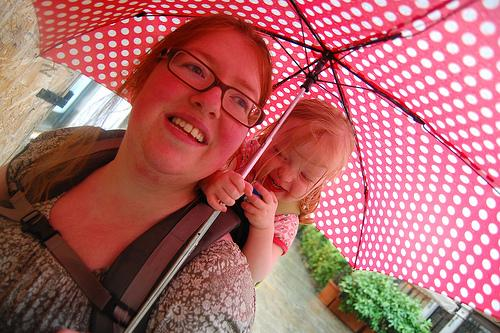What is the color of the straps on the woman's shoulders and what are they for? The straps are brown and belong to a black carrier harness. Where is the little girl in the image and what is she doing? The little girl is on the woman's back while holding the umbrella, and she is smiling. What pattern is present on the umbrella and in which colors? The umbrella is red with white polka dots. Describe the appearance of the woman in the image. The woman has red hair, blue eyes, and is wearing black glasses, a brown and white blouse, and a black carrier harness. Which object is silver and functions as support for the umbrella? The umbrella pole. Can you identify a plant-related item in the background and describe it briefly? There is a potted green plant in a terra cotta planter with green leaves, located on a brick paved sidewalk. Are there any living organisms or their parts visible in the image, and if so, what are they? Yes, there are green plants in pots, green leaves of a potted plant, and a green-trimmed hedge in the background. Mention the facial feature of the woman that helps her see better. The woman is wearing dark-colored glasses. What is the primary object that protects the two people from the rain? A red and white polka dotted umbrella. Tell me about the physical features of the little girl in this image. The little girl has blonde hair and is wearing a pink shirt. 